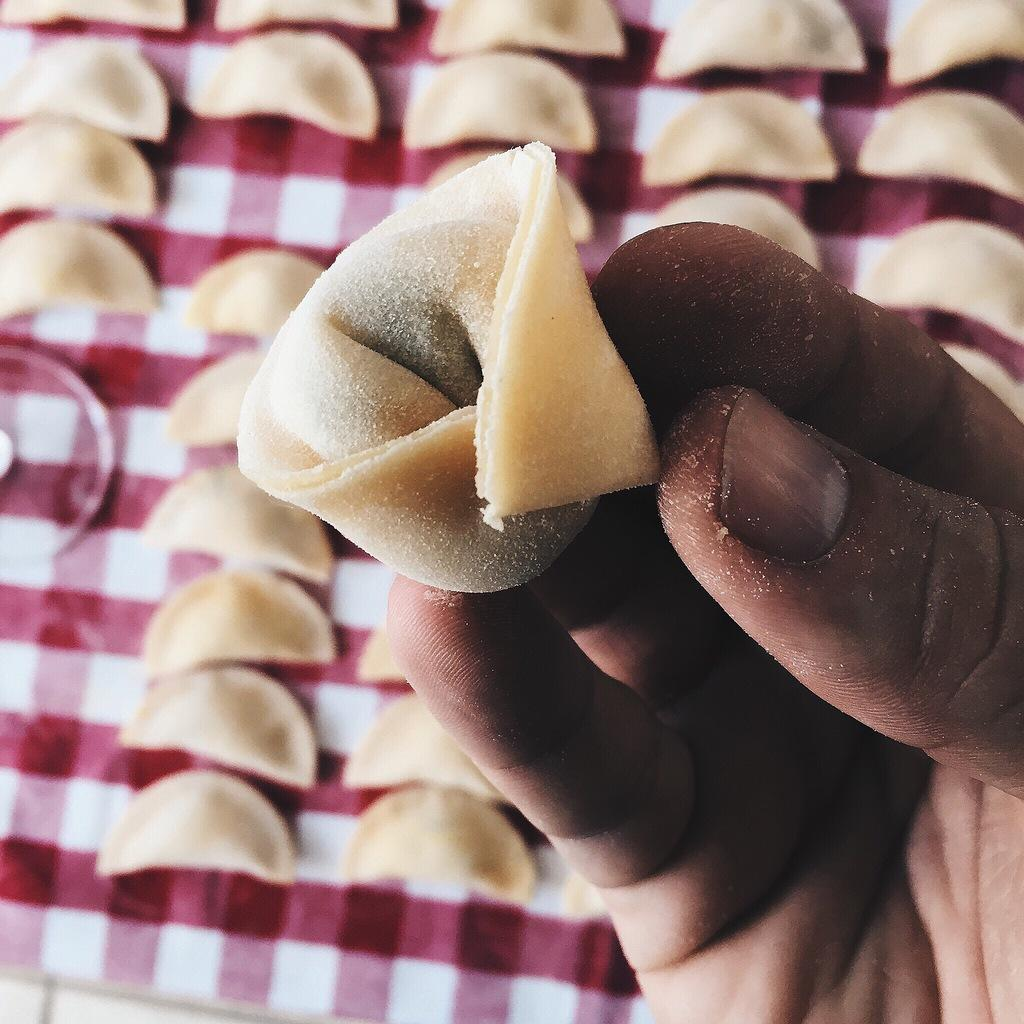What is the hand holding in the image? The hand is holding a cream-colored object in the image. Can you describe the objects in the background? There are multiple cream-colored objects in the background. What colors are present in the background cloth? The background cloth has red and white colors. How many beds are visible in the image? There are no beds present in the image. What type of cannon is being used for the distribution of the cream-colored objects? There is no cannon present in the image, and the cream-colored objects are not being distributed. 